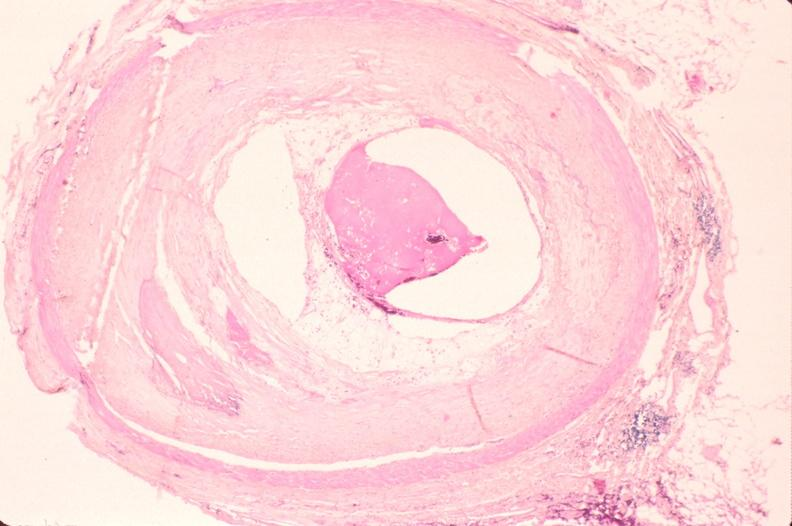s cachexia present?
Answer the question using a single word or phrase. No 